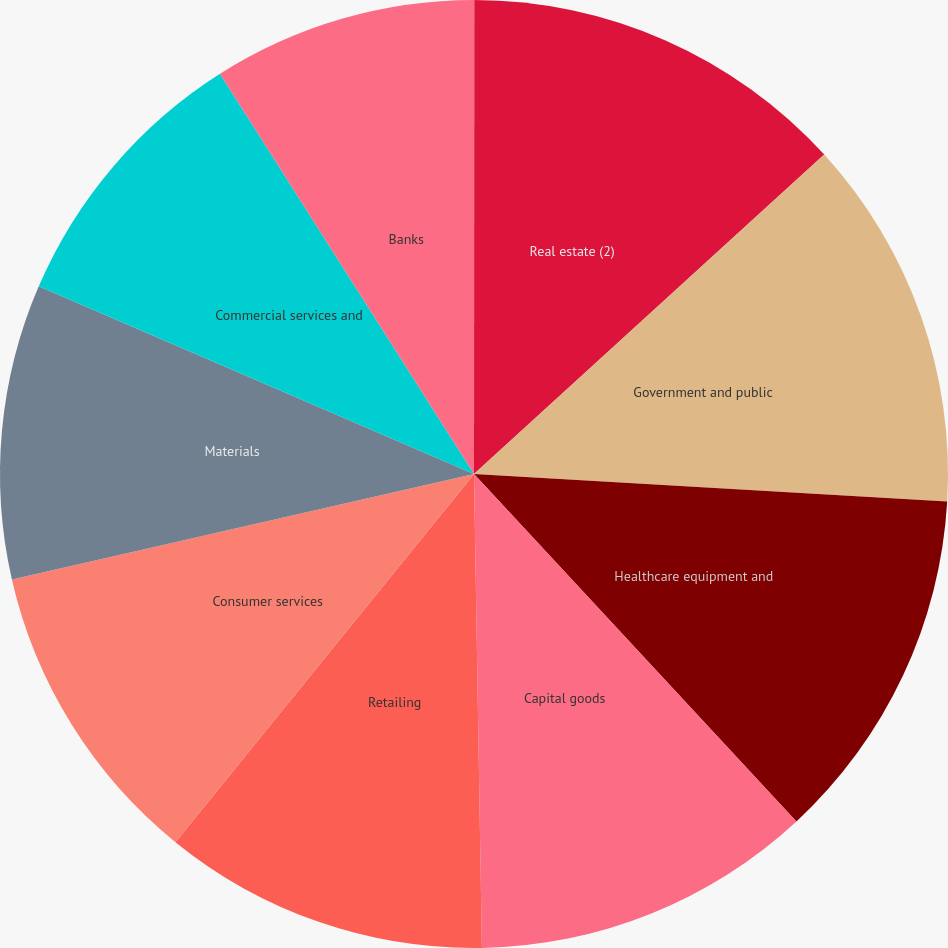Convert chart. <chart><loc_0><loc_0><loc_500><loc_500><pie_chart><fcel>(Dollars in millions)<fcel>Real estate (2)<fcel>Government and public<fcel>Healthcare equipment and<fcel>Capital goods<fcel>Retailing<fcel>Consumer services<fcel>Materials<fcel>Commercial services and<fcel>Banks<nl><fcel>0.01%<fcel>13.22%<fcel>12.69%<fcel>12.17%<fcel>11.64%<fcel>11.11%<fcel>10.58%<fcel>10.05%<fcel>9.52%<fcel>9.0%<nl></chart> 